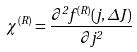<formula> <loc_0><loc_0><loc_500><loc_500>\chi ^ { ( R ) } = \frac { \partial ^ { 2 } f ^ { ( R ) } ( j , \Delta J ) } { \partial j ^ { 2 } }</formula> 